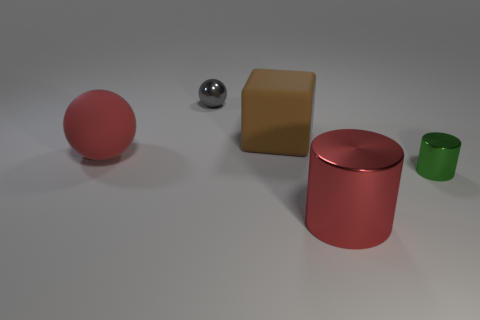What is the material of the large red thing that is in front of the rubber thing in front of the block that is behind the red matte sphere?
Your answer should be compact. Metal. Are there more small metal balls than red matte cubes?
Ensure brevity in your answer.  Yes. Is there anything else that has the same color as the large shiny thing?
Your response must be concise. Yes. What is the size of the other cylinder that is the same material as the green cylinder?
Make the answer very short. Large. What is the tiny green thing made of?
Ensure brevity in your answer.  Metal. What number of green cylinders have the same size as the gray metal thing?
Provide a short and direct response. 1. There is a thing that is the same color as the matte ball; what is its shape?
Offer a very short reply. Cylinder. Is there a large blue thing that has the same shape as the tiny green metallic object?
Make the answer very short. No. What color is the metal object that is the same size as the rubber sphere?
Ensure brevity in your answer.  Red. What color is the metallic cylinder on the left side of the small object that is in front of the big red matte sphere?
Offer a very short reply. Red. 